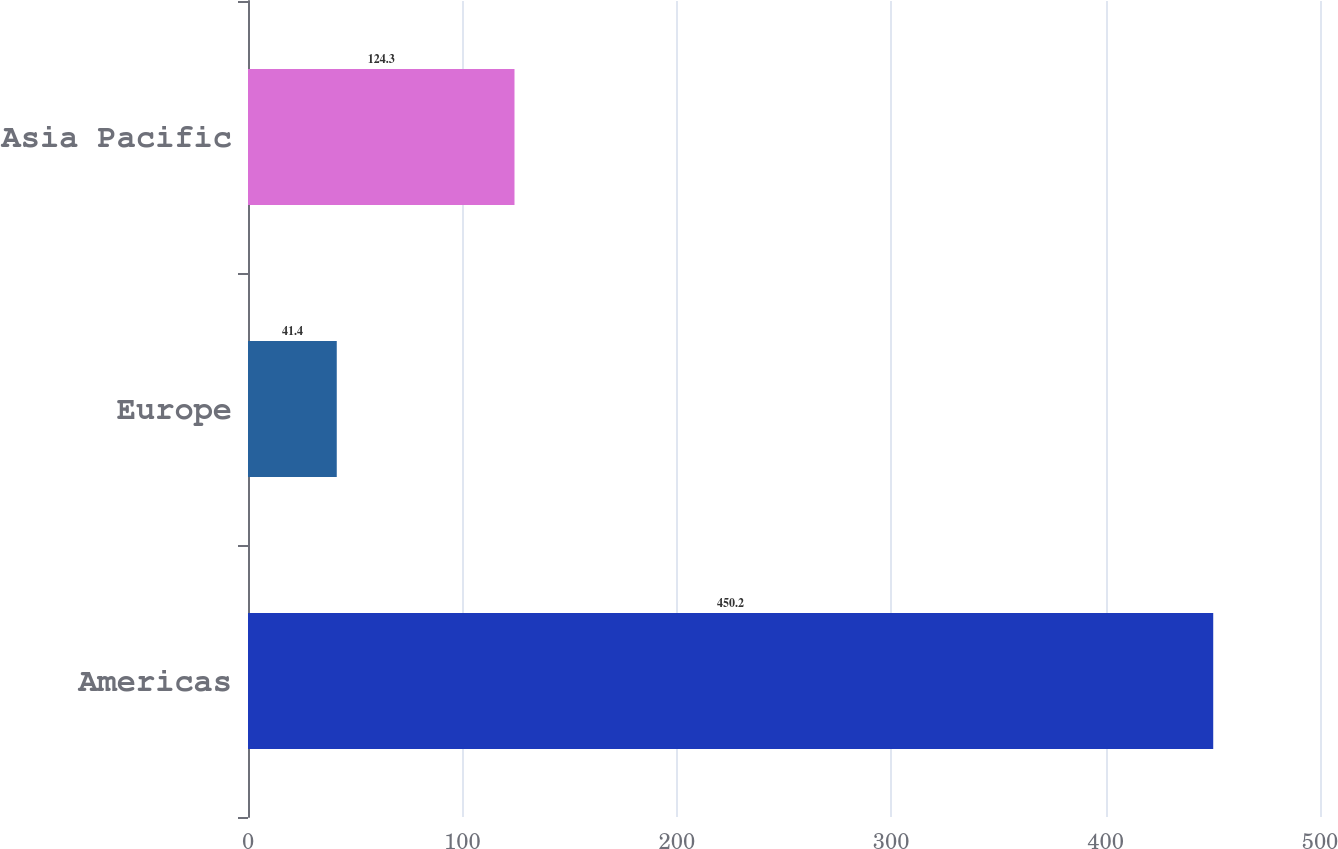Convert chart. <chart><loc_0><loc_0><loc_500><loc_500><bar_chart><fcel>Americas<fcel>Europe<fcel>Asia Pacific<nl><fcel>450.2<fcel>41.4<fcel>124.3<nl></chart> 